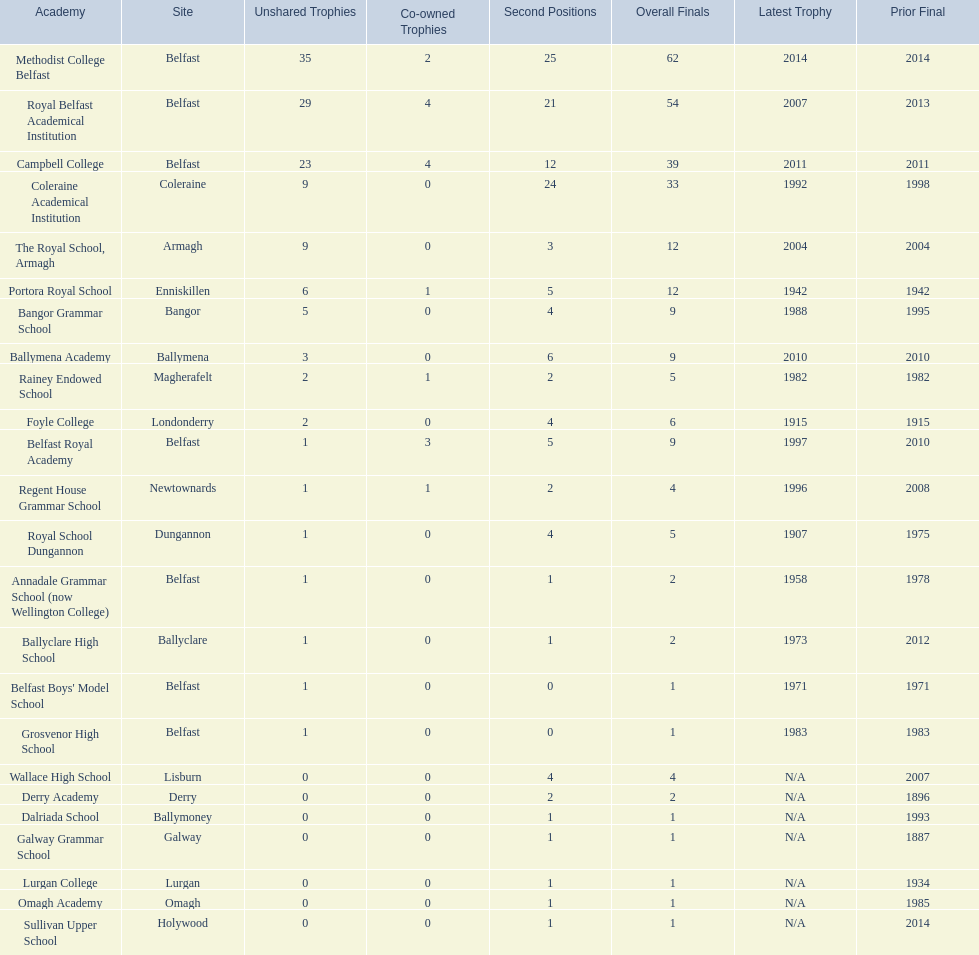How many schools are there? Methodist College Belfast, Royal Belfast Academical Institution, Campbell College, Coleraine Academical Institution, The Royal School, Armagh, Portora Royal School, Bangor Grammar School, Ballymena Academy, Rainey Endowed School, Foyle College, Belfast Royal Academy, Regent House Grammar School, Royal School Dungannon, Annadale Grammar School (now Wellington College), Ballyclare High School, Belfast Boys' Model School, Grosvenor High School, Wallace High School, Derry Academy, Dalriada School, Galway Grammar School, Lurgan College, Omagh Academy, Sullivan Upper School. How many outright titles does the coleraine academical institution have? 9. What other school has the same number of outright titles? The Royal School, Armagh. 